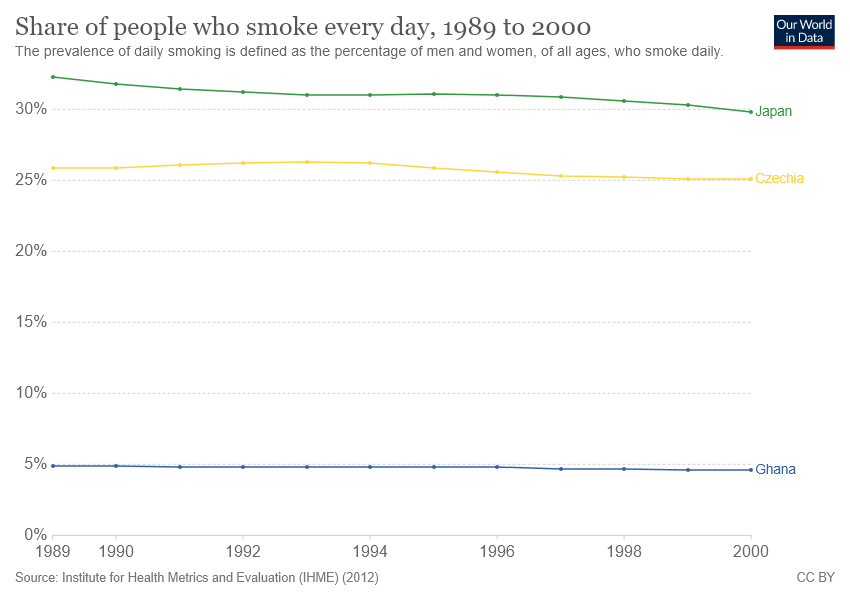Highlight a few significant elements in this photo. The given graph compares Japan and Czechia, and Ghana. According to recent data, there are several countries where more than 25% of the population smokes every day. 